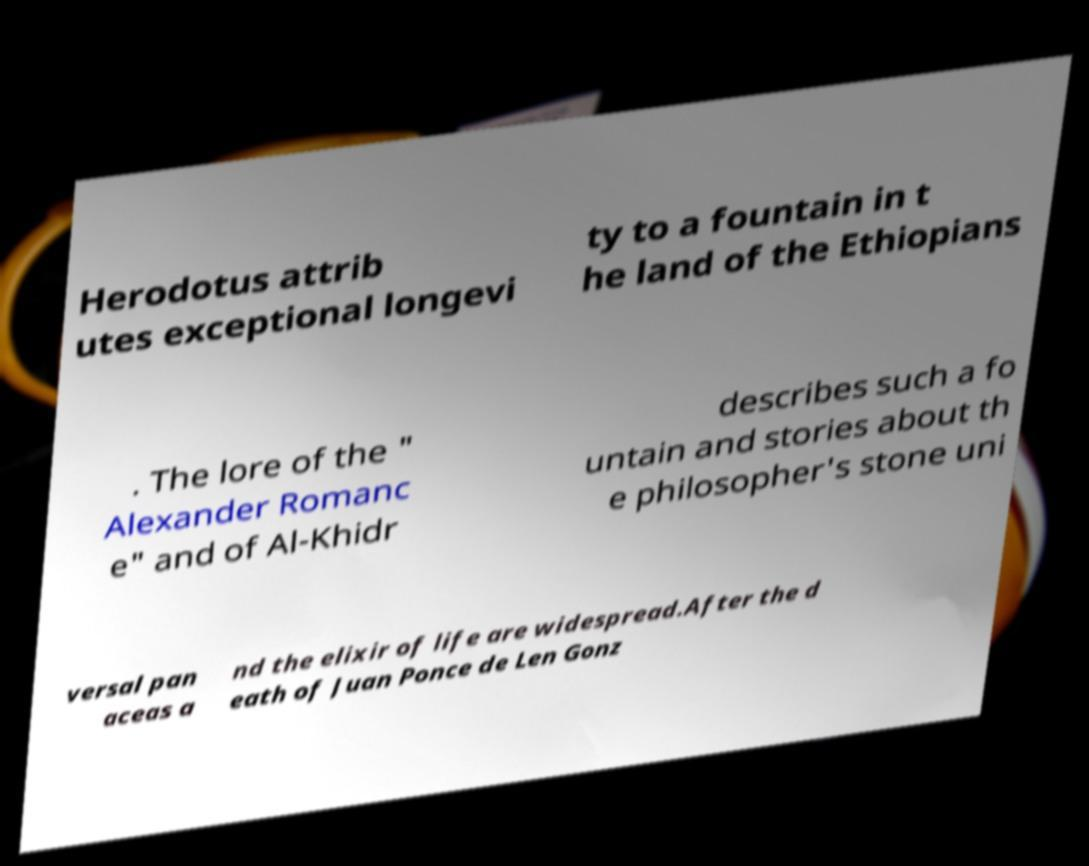Can you accurately transcribe the text from the provided image for me? Herodotus attrib utes exceptional longevi ty to a fountain in t he land of the Ethiopians . The lore of the " Alexander Romanc e" and of Al-Khidr describes such a fo untain and stories about th e philosopher's stone uni versal pan aceas a nd the elixir of life are widespread.After the d eath of Juan Ponce de Len Gonz 